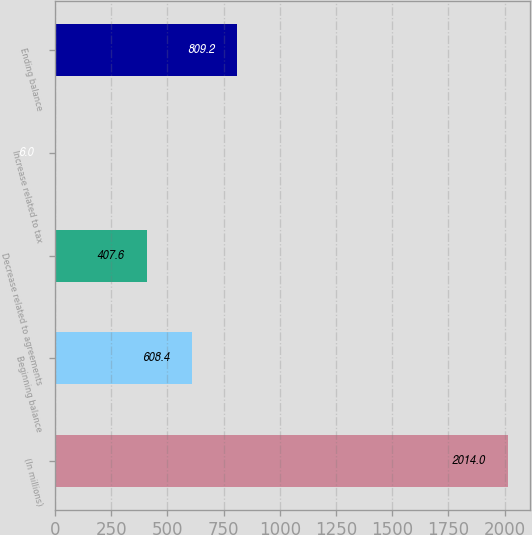<chart> <loc_0><loc_0><loc_500><loc_500><bar_chart><fcel>(In millions)<fcel>Beginning balance<fcel>Decrease related to agreements<fcel>Increase related to tax<fcel>Ending balance<nl><fcel>2014<fcel>608.4<fcel>407.6<fcel>6<fcel>809.2<nl></chart> 